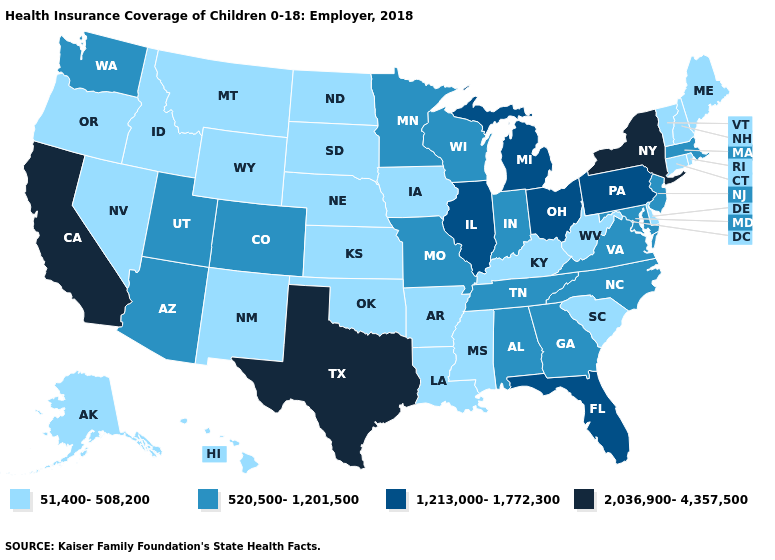Among the states that border Alabama , does Mississippi have the highest value?
Write a very short answer. No. Among the states that border Tennessee , does Arkansas have the lowest value?
Quick response, please. Yes. Is the legend a continuous bar?
Quick response, please. No. Name the states that have a value in the range 51,400-508,200?
Give a very brief answer. Alaska, Arkansas, Connecticut, Delaware, Hawaii, Idaho, Iowa, Kansas, Kentucky, Louisiana, Maine, Mississippi, Montana, Nebraska, Nevada, New Hampshire, New Mexico, North Dakota, Oklahoma, Oregon, Rhode Island, South Carolina, South Dakota, Vermont, West Virginia, Wyoming. What is the highest value in states that border Tennessee?
Keep it brief. 520,500-1,201,500. Which states have the lowest value in the South?
Quick response, please. Arkansas, Delaware, Kentucky, Louisiana, Mississippi, Oklahoma, South Carolina, West Virginia. What is the value of Maine?
Short answer required. 51,400-508,200. Name the states that have a value in the range 2,036,900-4,357,500?
Be succinct. California, New York, Texas. What is the value of New Hampshire?
Short answer required. 51,400-508,200. What is the value of Ohio?
Short answer required. 1,213,000-1,772,300. What is the highest value in the West ?
Short answer required. 2,036,900-4,357,500. Does the map have missing data?
Keep it brief. No. Name the states that have a value in the range 1,213,000-1,772,300?
Concise answer only. Florida, Illinois, Michigan, Ohio, Pennsylvania. Name the states that have a value in the range 2,036,900-4,357,500?
Quick response, please. California, New York, Texas. What is the value of Mississippi?
Give a very brief answer. 51,400-508,200. 